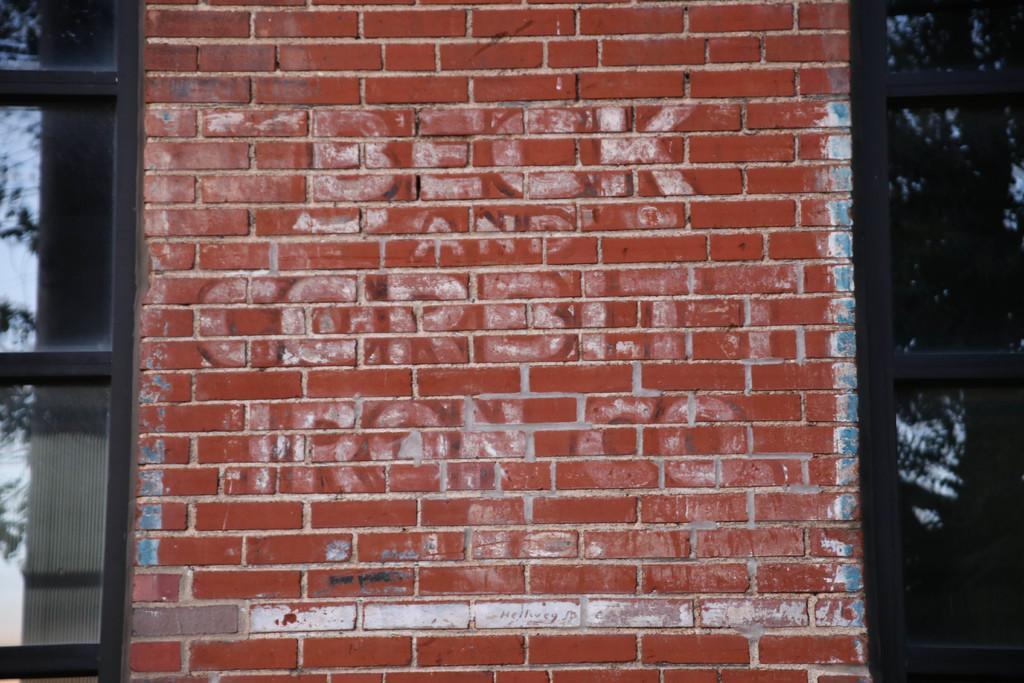How would you summarize this image in a sentence or two? In this image there is a brick wall, on that wall there is some text and there are windows. 